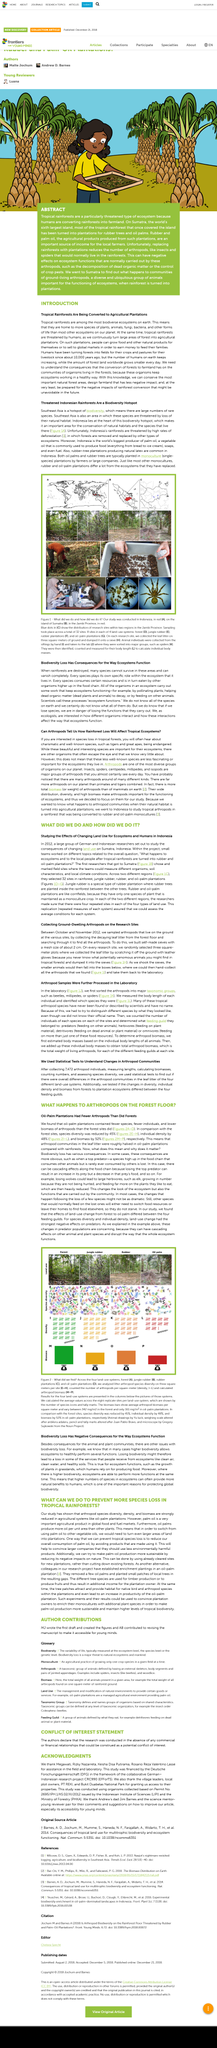Outline some significant characteristics in this image. Land use change had the strongest negative effects on predators. We propose planting trees for timber production alongside additional plants and trees that promote biodiversity as an alternative solution to make palm oil production more sustainable. The biodiversity in oil palm plantations is significantly lower than that of forests, with oil palm plantations having only 45% of the biodiversity of forests. The location of the red spot on the map in Picture A is the island of Sumatra. The article is titled "Threatened Indonesian Rainforests Are a Biodiversity Hotspot. 